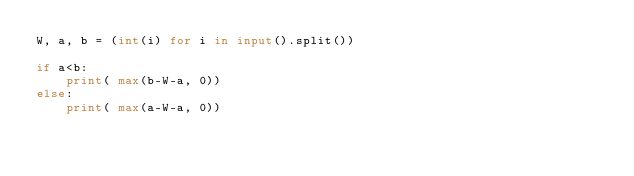<code> <loc_0><loc_0><loc_500><loc_500><_Python_>W, a, b = (int(i) for i in input().split())

if a<b:
    print( max(b-W-a, 0))
else:
    print( max(a-W-a, 0))</code> 